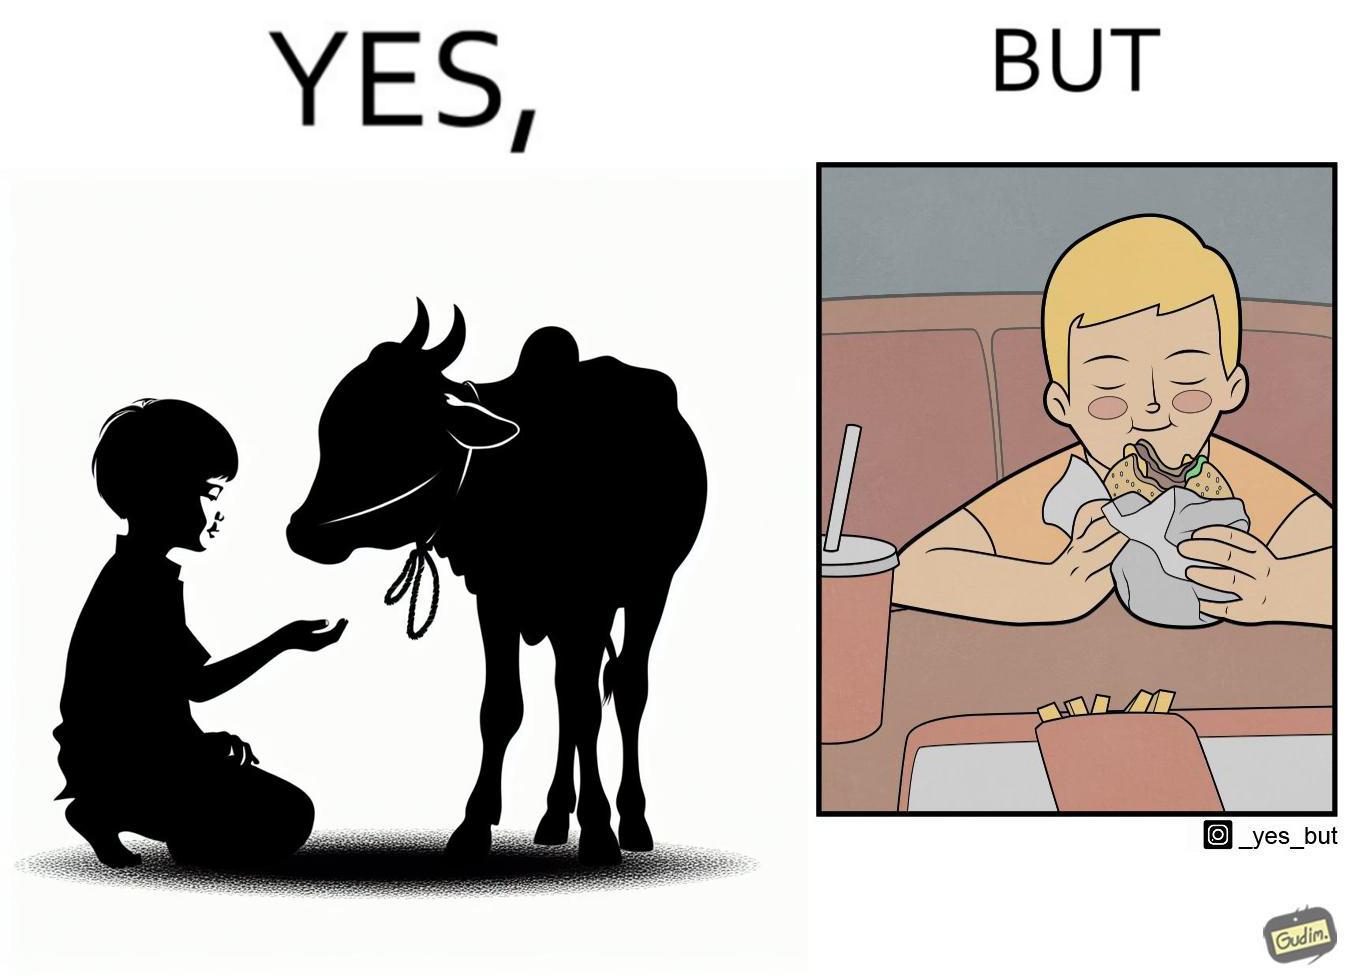Would you classify this image as satirical? Yes, this image is satirical. 